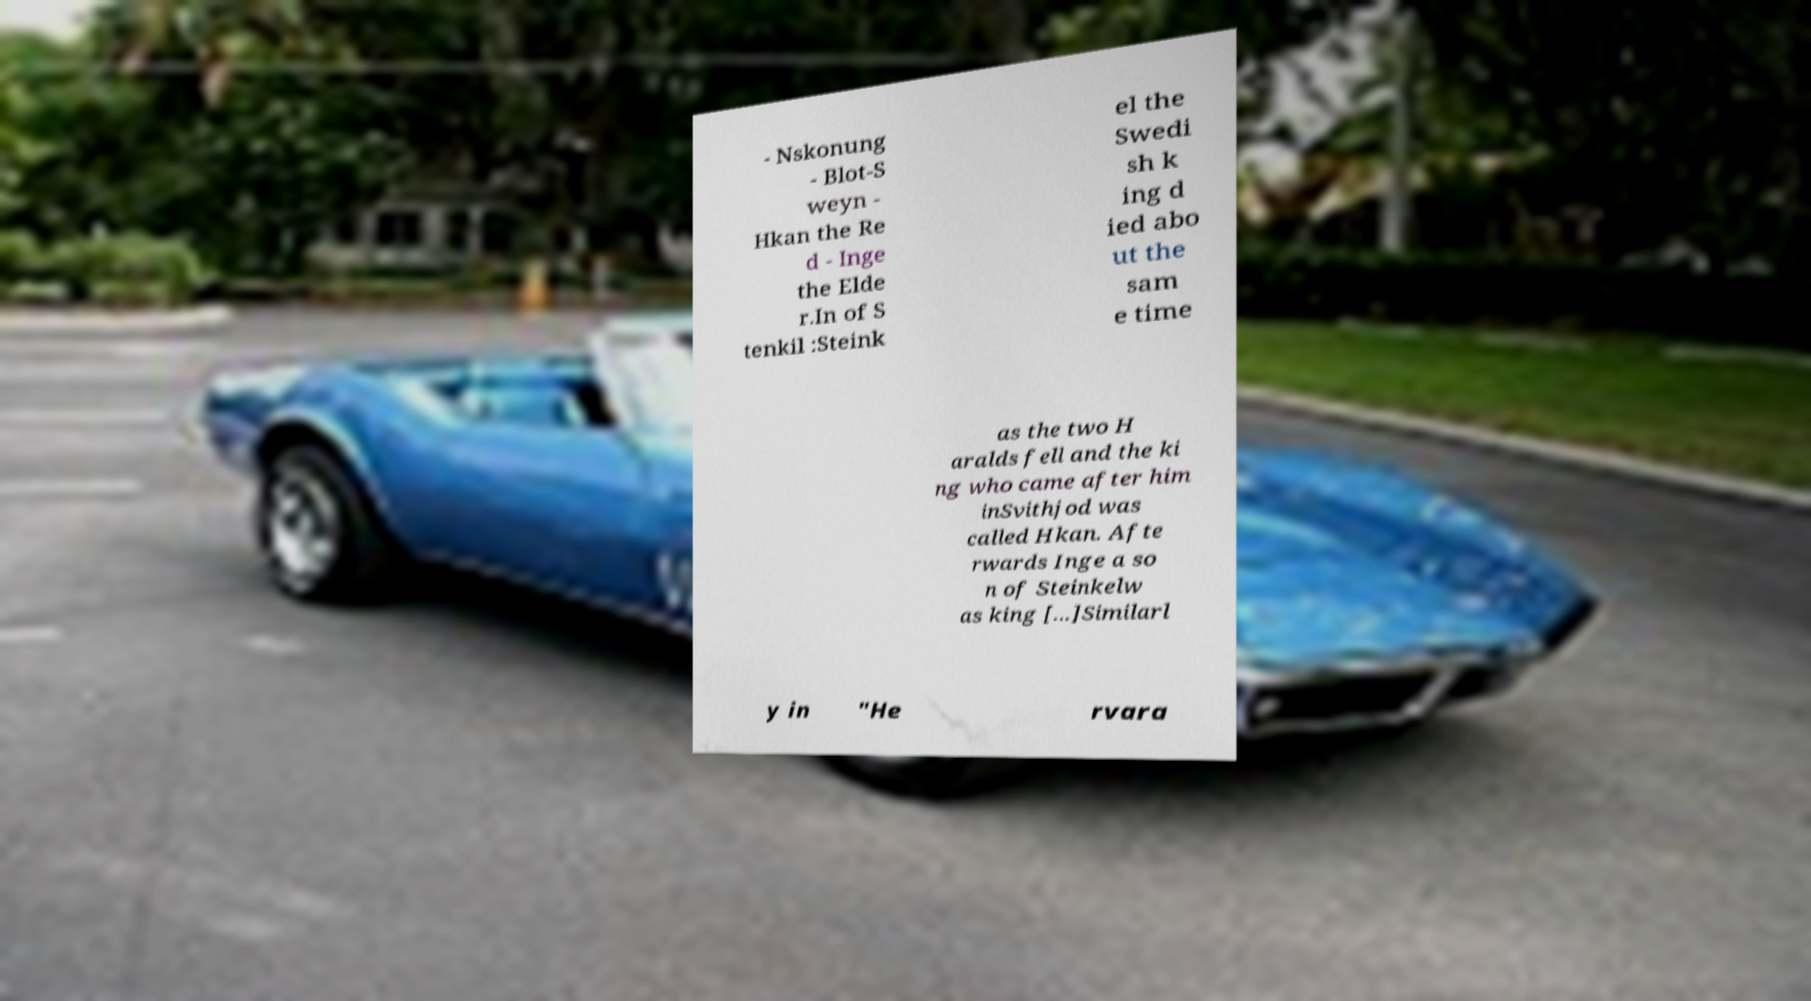Can you read and provide the text displayed in the image?This photo seems to have some interesting text. Can you extract and type it out for me? - Nskonung - Blot-S weyn - Hkan the Re d - Inge the Elde r.In of S tenkil :Steink el the Swedi sh k ing d ied abo ut the sam e time as the two H aralds fell and the ki ng who came after him inSvithjod was called Hkan. Afte rwards Inge a so n of Steinkelw as king [...]Similarl y in "He rvara 